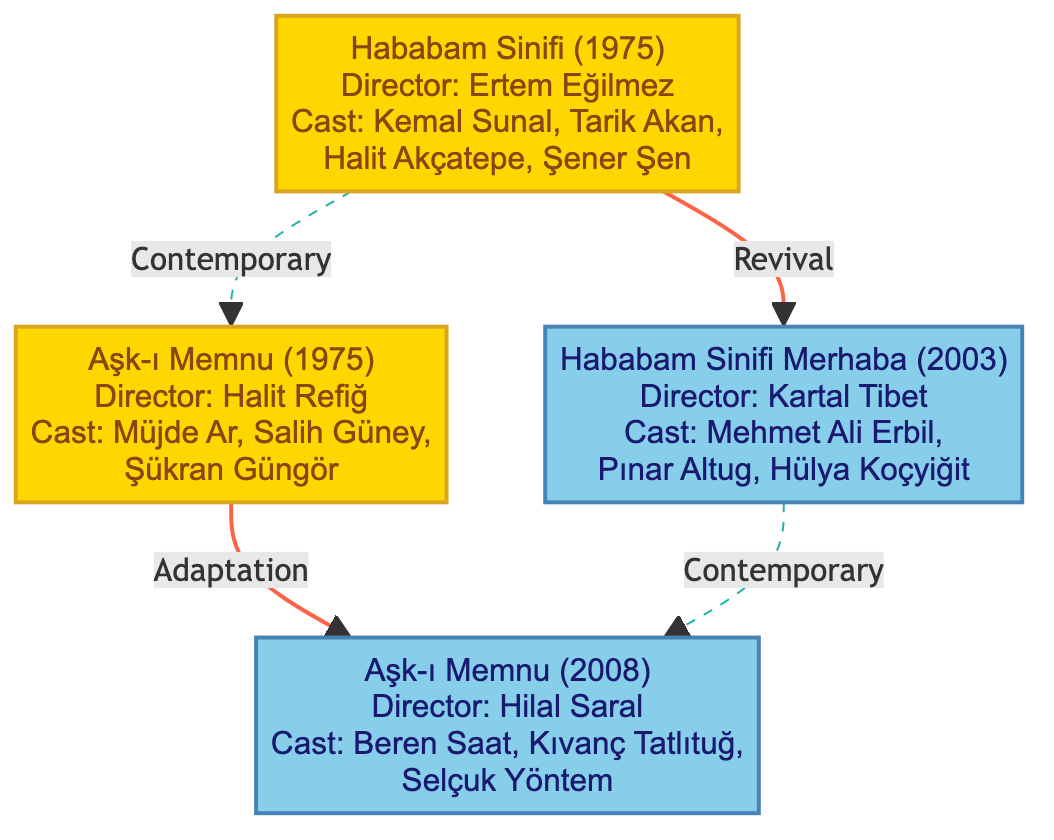What is the original airing year of Hababam Sinifi? The diagram indicates that Hababam Sinifi originally aired in 1975, as stated in the information provided for that show.
Answer: 1975 Who directed Aşk-ı Memnu (1975)? According to the diagram, Halit Refiğ is the director of the original Aşk-ı Memnu, which is explicitly mentioned in its details.
Answer: Halit Refiğ Which TV show has a modern revival titled "Hababam Sinifi Merhaba"? The diagram directly shows that "Hababam Sinifi" is the original show that has the modern revival "Hababam Sinifi Merhaba" linked to it, indicating that it belongs to the same family tree.
Answer: Hababam Sinifi How many nodes are there in the diagram? The diagram consists of four nodes, representing two original shows and their two modern revivals.
Answer: 4 What relationship is represented between Hababam Sinifi (1975) and Hababam Sinifi Merhaba? The diagram clearly indicates a revival relationship between the original show Hababam Sinifi and its revival, Hababam Sinifi Merhaba.
Answer: Revival What year was the modern adaptation of Aşk-ı Memnu released? The diagram specifies that the modern adaptation of Aşk-ı Memnu was aired in 2008, as shown in the details of that show.
Answer: 2008 Explain the connection between the two adaptations of Aşk-ı Memnu. The diagram shows that the original Aşk-ı Memnu from 1975 is connected to its modern adaptation from 2008 through an adaptation relationship. This indicates that the story was reinterpreted for a contemporary audience while maintaining its original themes. Therefore, the connection is that one is an adaptation of the other.
Answer: Adaptation Who are the main cast members of Hababam Sinifi Merhaba? The diagram presents the cast for the revival series "Hababam Sinifi Merhaba," listing Mehmet Ali Erbil, Pınar Altug, and Hülya Koçyiğit as the main cast, as specified in its details.
Answer: Mehmet Ali Erbil, Pınar Altug, Hülya Koçyiğit What genre does Hababam Sinifi primarily represent? The diagram describes Hababam Sinifi as a humorous take on high school students' lives, indicating that it falls under the comedy genre.
Answer: Humorous/Comedy 